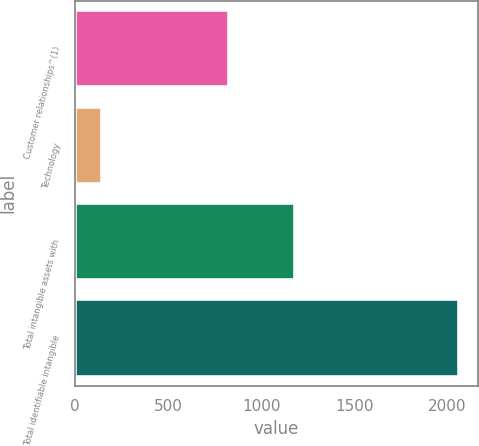Convert chart. <chart><loc_0><loc_0><loc_500><loc_500><bar_chart><fcel>Customer relationships^(1)<fcel>Technology<fcel>Total intangible assets with<fcel>Total identifiable intangible<nl><fcel>828.7<fcel>141.2<fcel>1179.9<fcel>2061.2<nl></chart> 